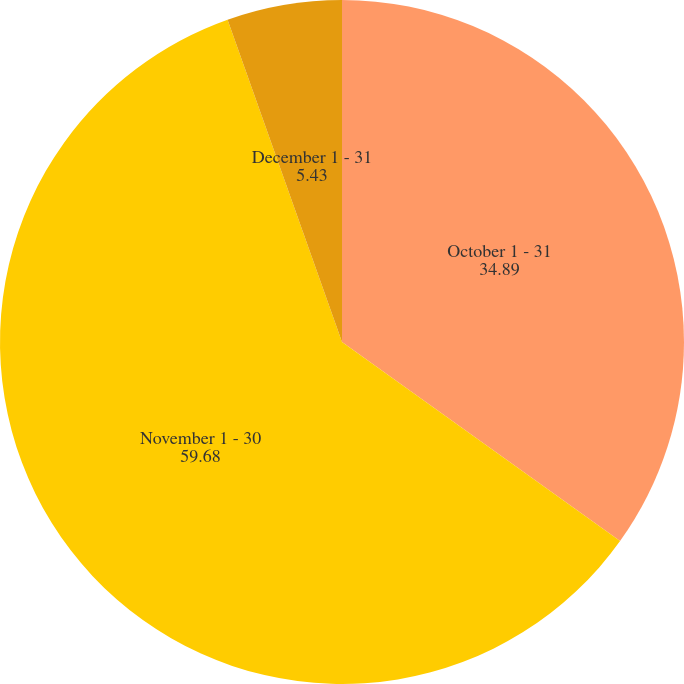Convert chart to OTSL. <chart><loc_0><loc_0><loc_500><loc_500><pie_chart><fcel>October 1 - 31<fcel>November 1 - 30<fcel>December 1 - 31<nl><fcel>34.89%<fcel>59.68%<fcel>5.43%<nl></chart> 